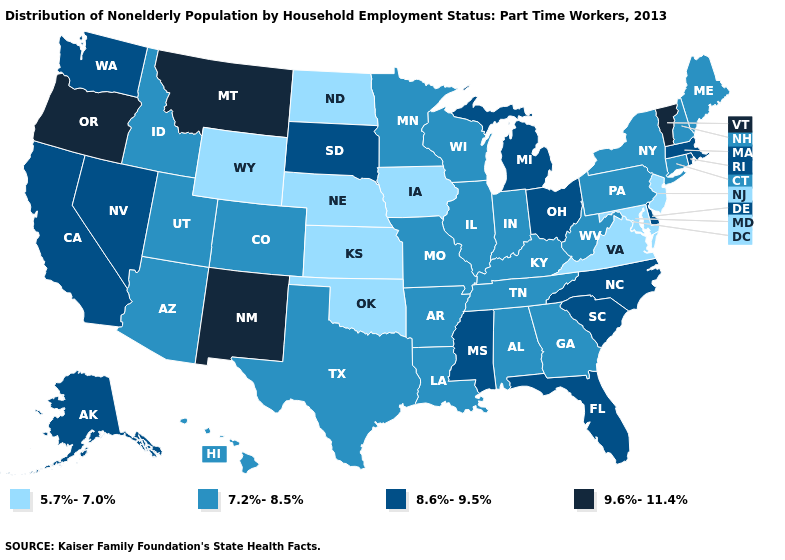Does the first symbol in the legend represent the smallest category?
Short answer required. Yes. Does Kentucky have a lower value than Alaska?
Write a very short answer. Yes. How many symbols are there in the legend?
Keep it brief. 4. Does the first symbol in the legend represent the smallest category?
Answer briefly. Yes. Is the legend a continuous bar?
Concise answer only. No. Name the states that have a value in the range 8.6%-9.5%?
Give a very brief answer. Alaska, California, Delaware, Florida, Massachusetts, Michigan, Mississippi, Nevada, North Carolina, Ohio, Rhode Island, South Carolina, South Dakota, Washington. What is the value of Pennsylvania?
Give a very brief answer. 7.2%-8.5%. Name the states that have a value in the range 8.6%-9.5%?
Answer briefly. Alaska, California, Delaware, Florida, Massachusetts, Michigan, Mississippi, Nevada, North Carolina, Ohio, Rhode Island, South Carolina, South Dakota, Washington. What is the highest value in states that border Kentucky?
Concise answer only. 8.6%-9.5%. Among the states that border New Mexico , which have the lowest value?
Be succinct. Oklahoma. Name the states that have a value in the range 8.6%-9.5%?
Quick response, please. Alaska, California, Delaware, Florida, Massachusetts, Michigan, Mississippi, Nevada, North Carolina, Ohio, Rhode Island, South Carolina, South Dakota, Washington. Name the states that have a value in the range 9.6%-11.4%?
Quick response, please. Montana, New Mexico, Oregon, Vermont. What is the lowest value in the USA?
Concise answer only. 5.7%-7.0%. Does New Hampshire have the highest value in the Northeast?
Short answer required. No. 